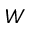Convert formula to latex. <formula><loc_0><loc_0><loc_500><loc_500>W</formula> 